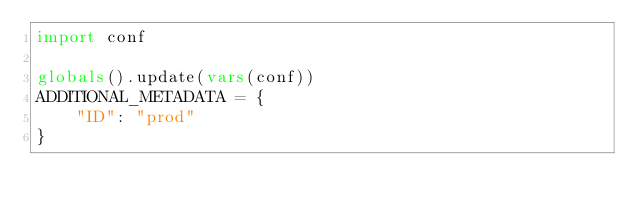<code> <loc_0><loc_0><loc_500><loc_500><_Python_>import conf

globals().update(vars(conf))
ADDITIONAL_METADATA = {
    "ID": "prod"
}
</code> 